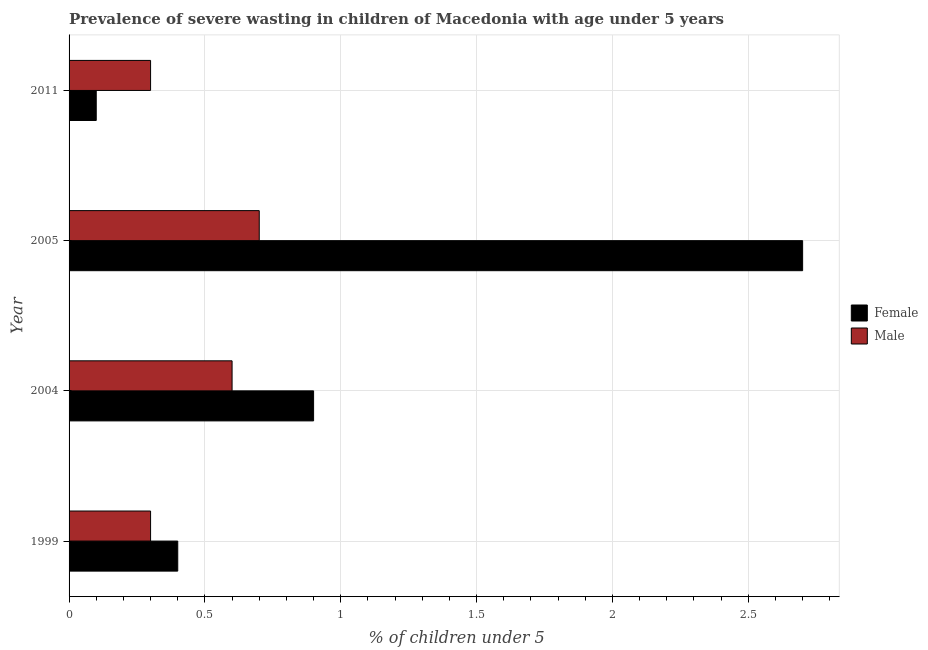How many different coloured bars are there?
Offer a terse response. 2. How many groups of bars are there?
Provide a succinct answer. 4. Are the number of bars per tick equal to the number of legend labels?
Provide a short and direct response. Yes. How many bars are there on the 1st tick from the top?
Your answer should be very brief. 2. How many bars are there on the 1st tick from the bottom?
Give a very brief answer. 2. What is the label of the 3rd group of bars from the top?
Offer a very short reply. 2004. What is the percentage of undernourished female children in 2011?
Keep it short and to the point. 0.1. Across all years, what is the maximum percentage of undernourished male children?
Offer a terse response. 0.7. Across all years, what is the minimum percentage of undernourished male children?
Your answer should be compact. 0.3. In which year was the percentage of undernourished male children maximum?
Ensure brevity in your answer.  2005. What is the total percentage of undernourished male children in the graph?
Ensure brevity in your answer.  1.9. What is the difference between the percentage of undernourished male children in 2005 and the percentage of undernourished female children in 1999?
Your response must be concise. 0.3. What is the average percentage of undernourished male children per year?
Your answer should be very brief. 0.47. In how many years, is the percentage of undernourished male children greater than 2.7 %?
Provide a succinct answer. 0. What is the ratio of the percentage of undernourished female children in 1999 to that in 2005?
Provide a succinct answer. 0.15. What is the difference between the highest and the second highest percentage of undernourished female children?
Offer a very short reply. 1.8. In how many years, is the percentage of undernourished male children greater than the average percentage of undernourished male children taken over all years?
Make the answer very short. 2. Is the sum of the percentage of undernourished male children in 1999 and 2011 greater than the maximum percentage of undernourished female children across all years?
Give a very brief answer. No. What does the 1st bar from the bottom in 1999 represents?
Provide a succinct answer. Female. Are all the bars in the graph horizontal?
Keep it short and to the point. Yes. How many years are there in the graph?
Ensure brevity in your answer.  4. Does the graph contain any zero values?
Your answer should be compact. No. Where does the legend appear in the graph?
Give a very brief answer. Center right. How many legend labels are there?
Keep it short and to the point. 2. How are the legend labels stacked?
Your response must be concise. Vertical. What is the title of the graph?
Offer a terse response. Prevalence of severe wasting in children of Macedonia with age under 5 years. Does "Long-term debt" appear as one of the legend labels in the graph?
Your response must be concise. No. What is the label or title of the X-axis?
Provide a succinct answer.  % of children under 5. What is the  % of children under 5 of Female in 1999?
Give a very brief answer. 0.4. What is the  % of children under 5 of Male in 1999?
Your response must be concise. 0.3. What is the  % of children under 5 in Female in 2005?
Make the answer very short. 2.7. What is the  % of children under 5 of Male in 2005?
Offer a terse response. 0.7. What is the  % of children under 5 in Female in 2011?
Offer a terse response. 0.1. What is the  % of children under 5 in Male in 2011?
Give a very brief answer. 0.3. Across all years, what is the maximum  % of children under 5 of Female?
Give a very brief answer. 2.7. Across all years, what is the maximum  % of children under 5 in Male?
Provide a short and direct response. 0.7. Across all years, what is the minimum  % of children under 5 of Female?
Make the answer very short. 0.1. Across all years, what is the minimum  % of children under 5 of Male?
Ensure brevity in your answer.  0.3. What is the difference between the  % of children under 5 of Female in 1999 and that in 2004?
Provide a short and direct response. -0.5. What is the difference between the  % of children under 5 in Male in 2004 and that in 2005?
Ensure brevity in your answer.  -0.1. What is the difference between the  % of children under 5 of Female in 2004 and that in 2011?
Offer a terse response. 0.8. What is the difference between the  % of children under 5 of Female in 1999 and the  % of children under 5 of Male in 2004?
Offer a terse response. -0.2. What is the difference between the  % of children under 5 of Female in 2004 and the  % of children under 5 of Male in 2005?
Offer a very short reply. 0.2. What is the difference between the  % of children under 5 in Female in 2004 and the  % of children under 5 in Male in 2011?
Ensure brevity in your answer.  0.6. What is the difference between the  % of children under 5 in Female in 2005 and the  % of children under 5 in Male in 2011?
Ensure brevity in your answer.  2.4. What is the average  % of children under 5 in Male per year?
Offer a terse response. 0.47. In the year 1999, what is the difference between the  % of children under 5 in Female and  % of children under 5 in Male?
Offer a terse response. 0.1. In the year 2005, what is the difference between the  % of children under 5 of Female and  % of children under 5 of Male?
Your answer should be compact. 2. In the year 2011, what is the difference between the  % of children under 5 of Female and  % of children under 5 of Male?
Ensure brevity in your answer.  -0.2. What is the ratio of the  % of children under 5 of Female in 1999 to that in 2004?
Give a very brief answer. 0.44. What is the ratio of the  % of children under 5 of Female in 1999 to that in 2005?
Offer a terse response. 0.15. What is the ratio of the  % of children under 5 of Male in 1999 to that in 2005?
Keep it short and to the point. 0.43. What is the ratio of the  % of children under 5 of Female in 1999 to that in 2011?
Make the answer very short. 4. What is the ratio of the  % of children under 5 in Male in 1999 to that in 2011?
Provide a succinct answer. 1. What is the ratio of the  % of children under 5 in Female in 2004 to that in 2005?
Make the answer very short. 0.33. What is the ratio of the  % of children under 5 in Male in 2004 to that in 2005?
Ensure brevity in your answer.  0.86. What is the ratio of the  % of children under 5 in Male in 2004 to that in 2011?
Ensure brevity in your answer.  2. What is the ratio of the  % of children under 5 of Female in 2005 to that in 2011?
Offer a terse response. 27. What is the ratio of the  % of children under 5 of Male in 2005 to that in 2011?
Ensure brevity in your answer.  2.33. What is the difference between the highest and the second highest  % of children under 5 in Female?
Ensure brevity in your answer.  1.8. What is the difference between the highest and the second highest  % of children under 5 of Male?
Ensure brevity in your answer.  0.1. 